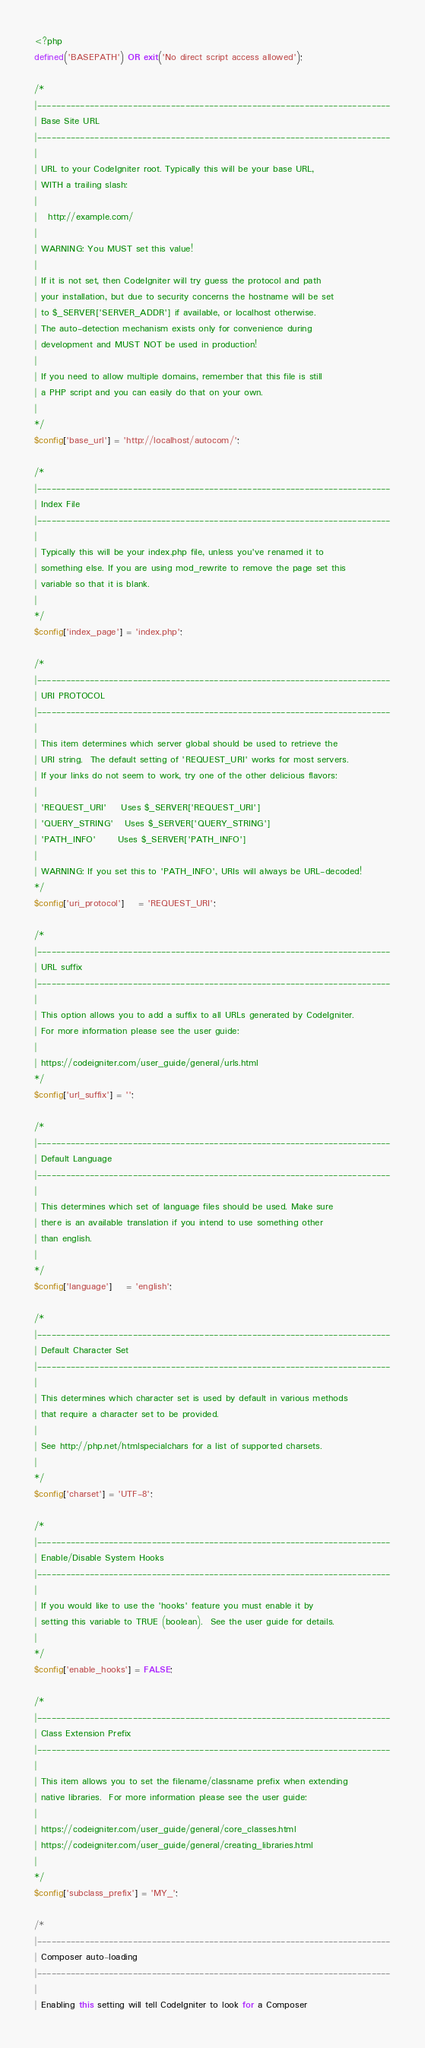Convert code to text. <code><loc_0><loc_0><loc_500><loc_500><_PHP_><?php
defined('BASEPATH') OR exit('No direct script access allowed');

/*
|--------------------------------------------------------------------------
| Base Site URL
|--------------------------------------------------------------------------
|
| URL to your CodeIgniter root. Typically this will be your base URL,
| WITH a trailing slash:
|
|	http://example.com/
|
| WARNING: You MUST set this value!
|
| If it is not set, then CodeIgniter will try guess the protocol and path
| your installation, but due to security concerns the hostname will be set
| to $_SERVER['SERVER_ADDR'] if available, or localhost otherwise.
| The auto-detection mechanism exists only for convenience during
| development and MUST NOT be used in production!
|
| If you need to allow multiple domains, remember that this file is still
| a PHP script and you can easily do that on your own.
|
*/
$config['base_url'] = 'http://localhost/autocom/';

/*
|--------------------------------------------------------------------------
| Index File
|--------------------------------------------------------------------------
|
| Typically this will be your index.php file, unless you've renamed it to
| something else. If you are using mod_rewrite to remove the page set this
| variable so that it is blank.
|
*/
$config['index_page'] = 'index.php';

/*
|--------------------------------------------------------------------------
| URI PROTOCOL
|--------------------------------------------------------------------------
|
| This item determines which server global should be used to retrieve the
| URI string.  The default setting of 'REQUEST_URI' works for most servers.
| If your links do not seem to work, try one of the other delicious flavors:
|
| 'REQUEST_URI'    Uses $_SERVER['REQUEST_URI']
| 'QUERY_STRING'   Uses $_SERVER['QUERY_STRING']
| 'PATH_INFO'      Uses $_SERVER['PATH_INFO']
|
| WARNING: If you set this to 'PATH_INFO', URIs will always be URL-decoded!
*/
$config['uri_protocol']	= 'REQUEST_URI';

/*
|--------------------------------------------------------------------------
| URL suffix
|--------------------------------------------------------------------------
|
| This option allows you to add a suffix to all URLs generated by CodeIgniter.
| For more information please see the user guide:
|
| https://codeigniter.com/user_guide/general/urls.html
*/
$config['url_suffix'] = '';

/*
|--------------------------------------------------------------------------
| Default Language
|--------------------------------------------------------------------------
|
| This determines which set of language files should be used. Make sure
| there is an available translation if you intend to use something other
| than english.
|
*/
$config['language']	= 'english';

/*
|--------------------------------------------------------------------------
| Default Character Set
|--------------------------------------------------------------------------
|
| This determines which character set is used by default in various methods
| that require a character set to be provided.
|
| See http://php.net/htmlspecialchars for a list of supported charsets.
|
*/
$config['charset'] = 'UTF-8';

/*
|--------------------------------------------------------------------------
| Enable/Disable System Hooks
|--------------------------------------------------------------------------
|
| If you would like to use the 'hooks' feature you must enable it by
| setting this variable to TRUE (boolean).  See the user guide for details.
|
*/
$config['enable_hooks'] = FALSE;

/*
|--------------------------------------------------------------------------
| Class Extension Prefix
|--------------------------------------------------------------------------
|
| This item allows you to set the filename/classname prefix when extending
| native libraries.  For more information please see the user guide:
|
| https://codeigniter.com/user_guide/general/core_classes.html
| https://codeigniter.com/user_guide/general/creating_libraries.html
|
*/
$config['subclass_prefix'] = 'MY_';

/*
|--------------------------------------------------------------------------
| Composer auto-loading
|--------------------------------------------------------------------------
|
| Enabling this setting will tell CodeIgniter to look for a Composer</code> 